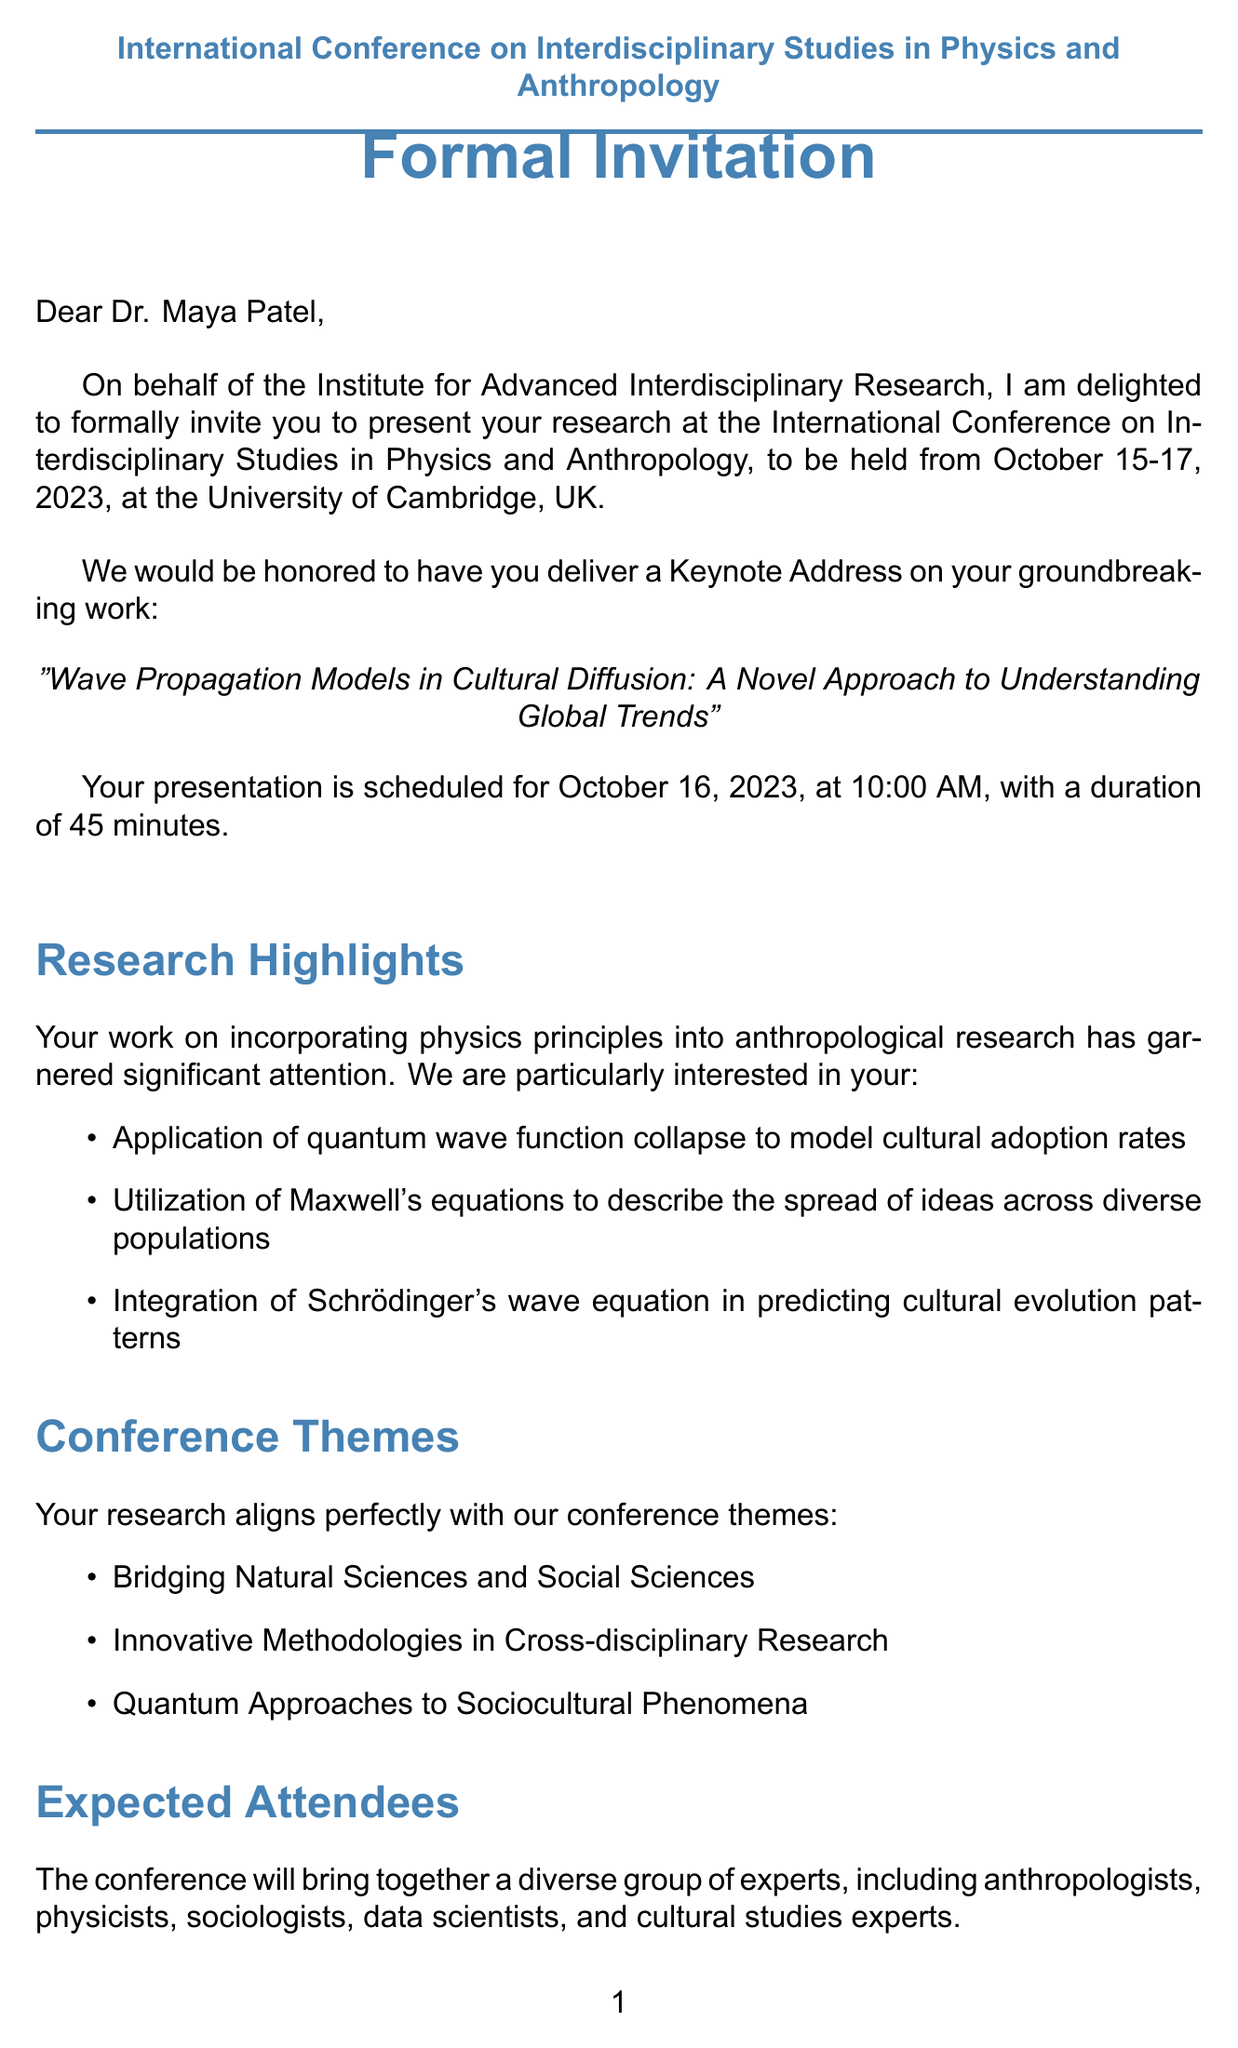What is the name of the conference? The name of the conference is explicitly mentioned in the document, which is "International Conference on Interdisciplinary Studies in Physics and Anthropology."
Answer: International Conference on Interdisciplinary Studies in Physics and Anthropology Who is the recipient of the invitation? The recipient's name is stated in the invitation details section of the document as "Dr. Maya Patel."
Answer: Dr. Maya Patel What is the date of the keynote address? The specific date for the scheduled keynote address is found in the invitation details section, which is "October 16, 2023."
Answer: October 16, 2023 How long is the presentation duration? The document states the duration of the presentation, which is "45 minutes."
Answer: 45 minutes What is one of the research highlights mentioned? The document includes a list of research highlights; one example is "Application of quantum wave function collapse to model cultural adoption rates."
Answer: Application of quantum wave function collapse to model cultural adoption rates What are the expected attendees of the conference? The document lists a type of attendees, which includes "Anthropologists."
Answer: Anthropologists What are the submission requirements for the abstract? The document specifies the abstract deadline and word limit; it says "July 31, 2023 (300-word limit)."
Answer: July 31, 2023 (300-word limit) What is the accommodation suggestion listed in the travel information? An example of accommodation suggested in the travel information section is "The Gonville Hotel."
Answer: The Gonville Hotel 